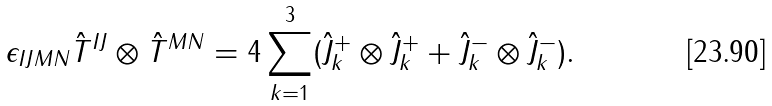<formula> <loc_0><loc_0><loc_500><loc_500>\epsilon _ { I J M N } \hat { T } ^ { I J } \otimes \hat { T } ^ { M N } = 4 \sum _ { k = 1 } ^ { 3 } ( \hat { J } ^ { + } _ { k } \otimes \hat { J } ^ { + } _ { k } + \hat { J } ^ { - } _ { k } \otimes \hat { J } ^ { - } _ { k } ) .</formula> 